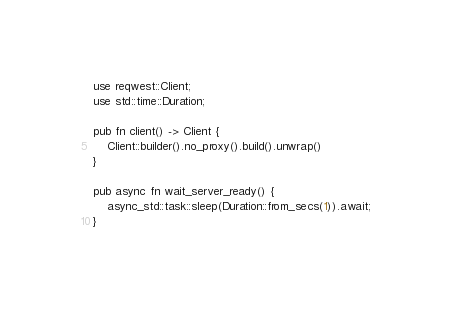Convert code to text. <code><loc_0><loc_0><loc_500><loc_500><_Rust_>use reqwest::Client;
use std::time::Duration;

pub fn client() -> Client {
    Client::builder().no_proxy().build().unwrap()
}

pub async fn wait_server_ready() {
    async_std::task::sleep(Duration::from_secs(1)).await;
}
</code> 